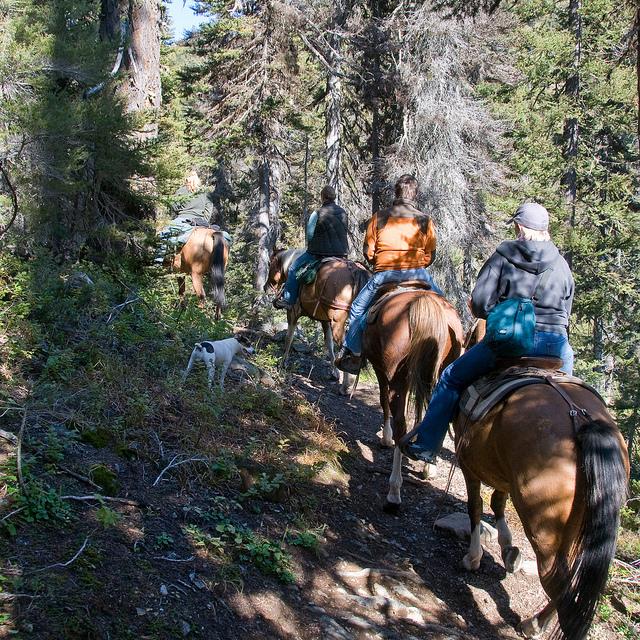Are they in the woods?
Give a very brief answer. Yes. What color is the tail of the horse in the back of the line?
Short answer required. Black. Are they on a trail?
Quick response, please. Yes. 